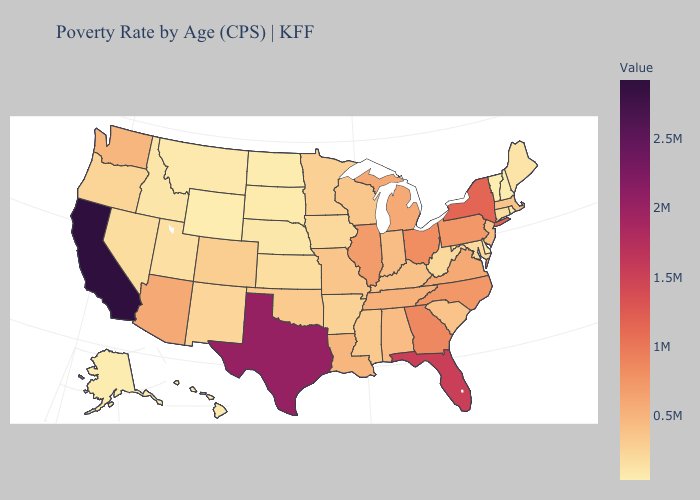Does Wyoming have the lowest value in the USA?
Quick response, please. Yes. Does New York have the highest value in the Northeast?
Be succinct. Yes. Does Wyoming have the lowest value in the USA?
Quick response, please. Yes. Does West Virginia have the lowest value in the USA?
Write a very short answer. No. Does California have the highest value in the West?
Write a very short answer. Yes. Does New Hampshire have a lower value than New York?
Concise answer only. Yes. 